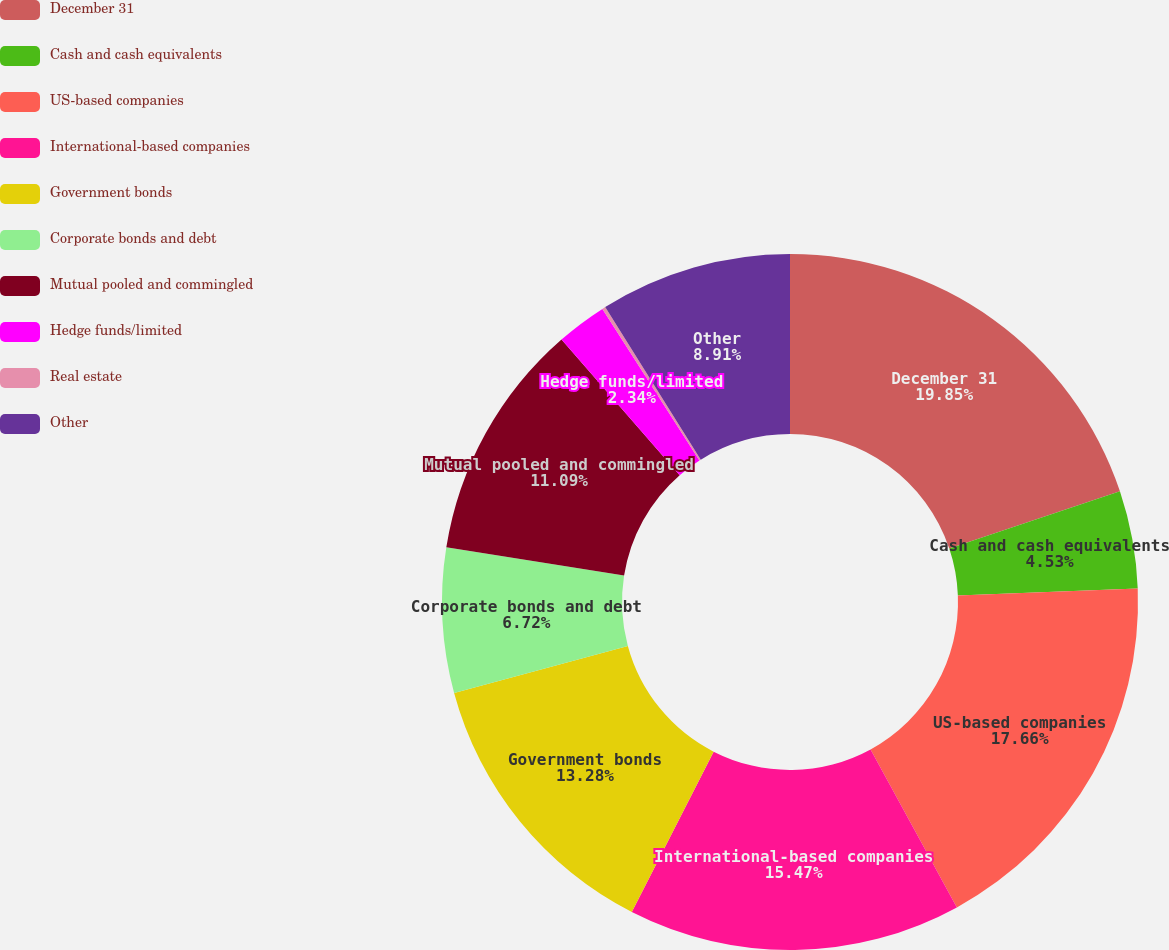Convert chart. <chart><loc_0><loc_0><loc_500><loc_500><pie_chart><fcel>December 31<fcel>Cash and cash equivalents<fcel>US-based companies<fcel>International-based companies<fcel>Government bonds<fcel>Corporate bonds and debt<fcel>Mutual pooled and commingled<fcel>Hedge funds/limited<fcel>Real estate<fcel>Other<nl><fcel>19.85%<fcel>4.53%<fcel>17.66%<fcel>15.47%<fcel>13.28%<fcel>6.72%<fcel>11.09%<fcel>2.34%<fcel>0.15%<fcel>8.91%<nl></chart> 